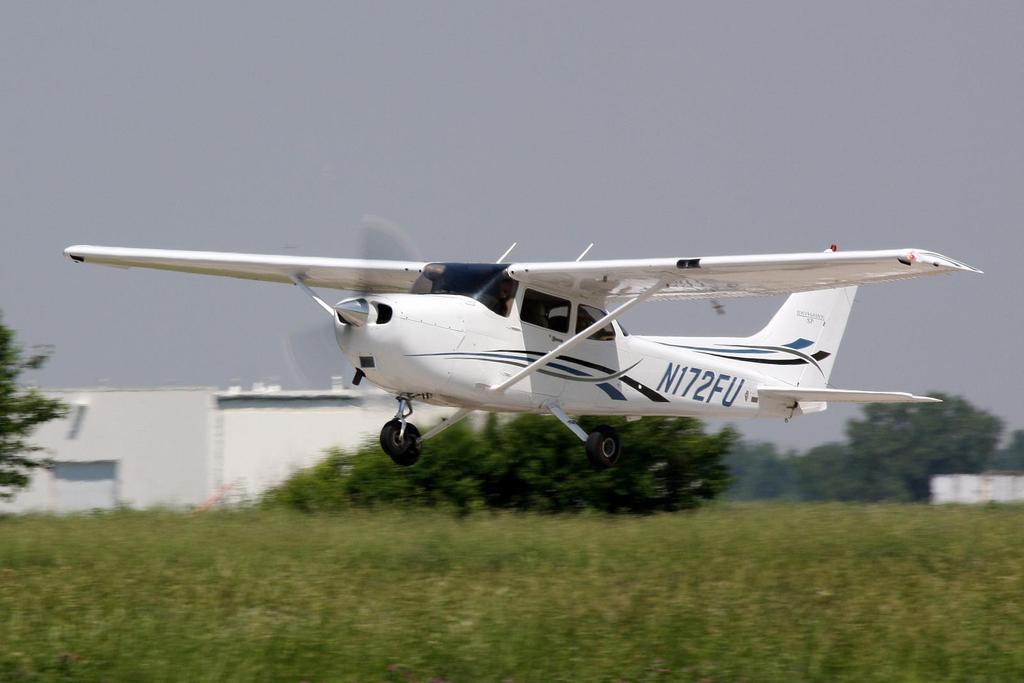In one or two sentences, can you explain what this image depicts? In this image, we can see some trees and plants. There is a shelter on the left side of the image. There is an airplane in the middle of the image. There is a sky at the top of the image. 